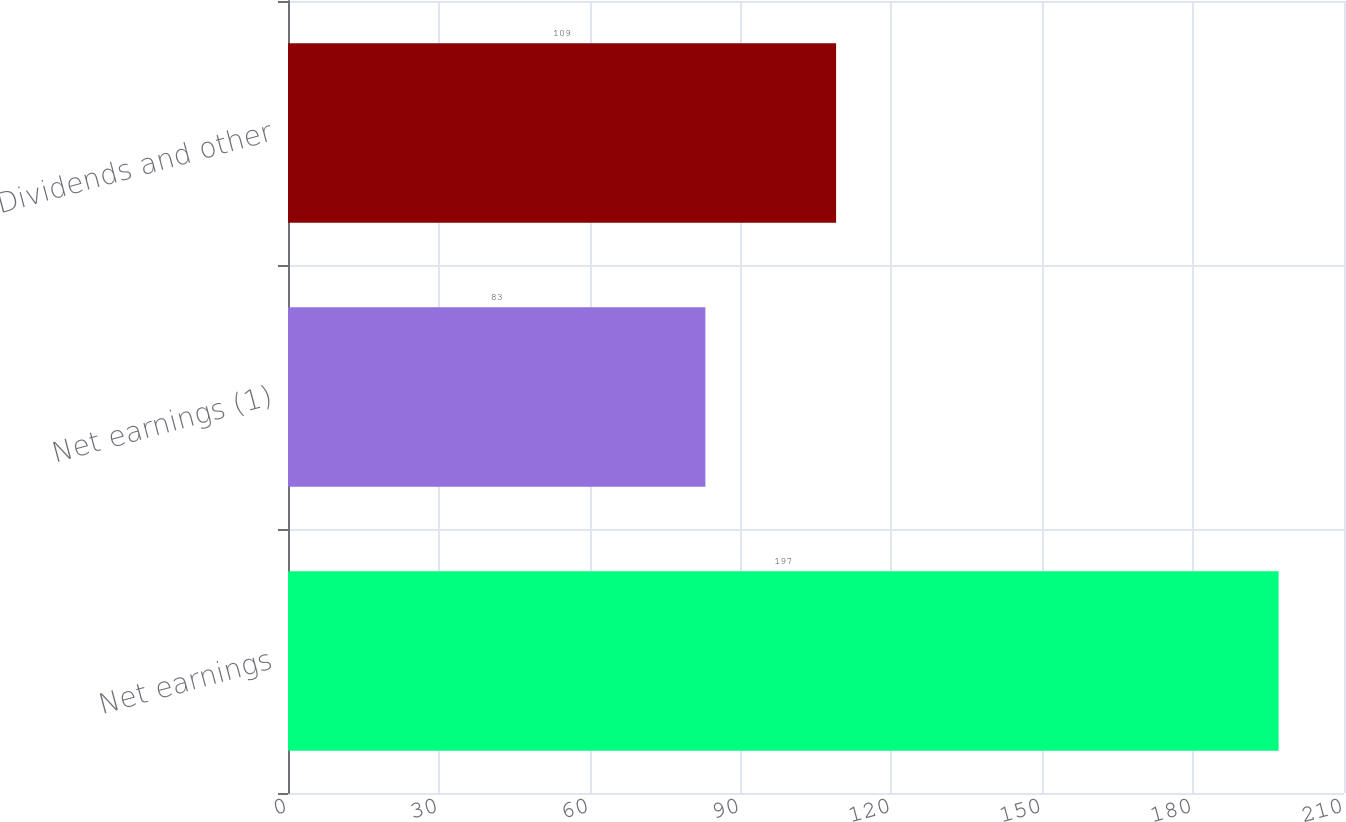<chart> <loc_0><loc_0><loc_500><loc_500><bar_chart><fcel>Net earnings<fcel>Net earnings (1)<fcel>Dividends and other<nl><fcel>197<fcel>83<fcel>109<nl></chart> 